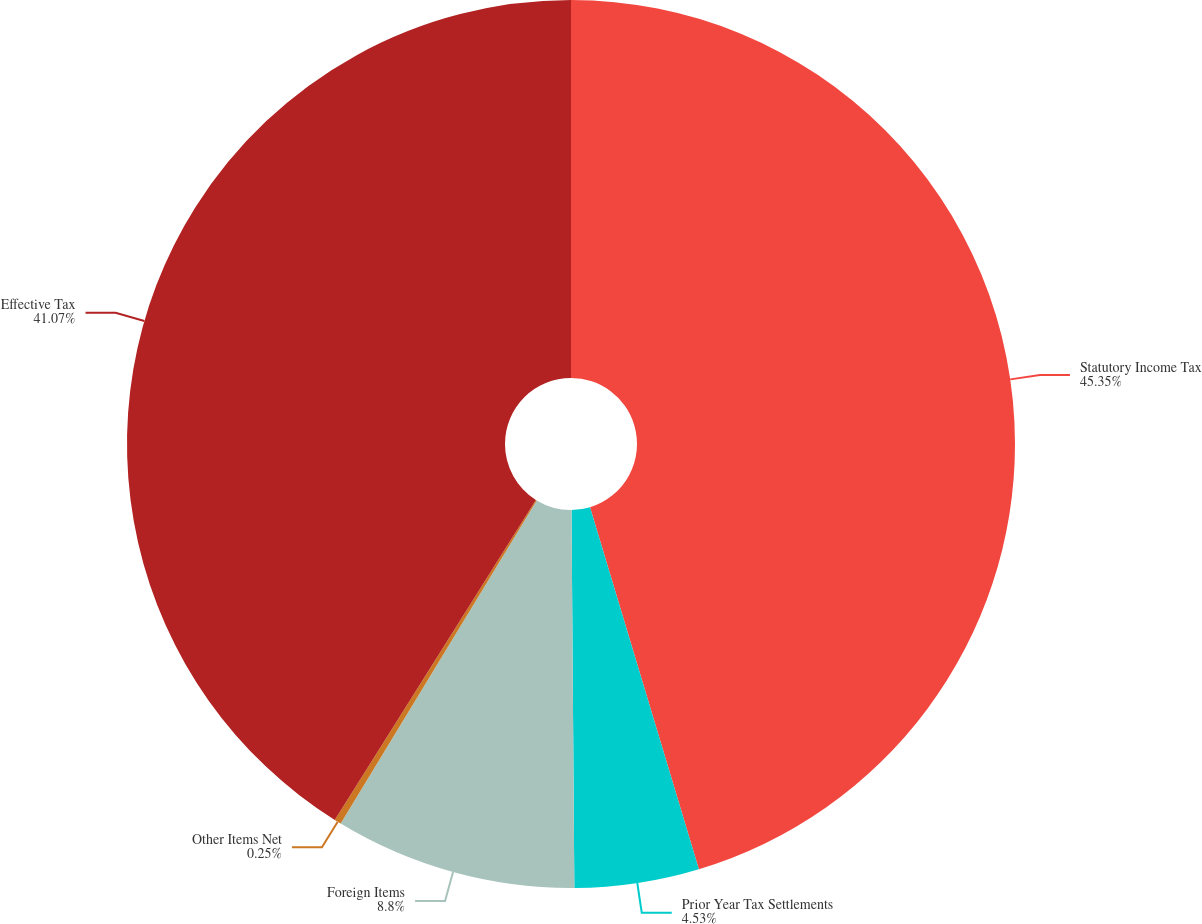Convert chart. <chart><loc_0><loc_0><loc_500><loc_500><pie_chart><fcel>Statutory Income Tax<fcel>Prior Year Tax Settlements<fcel>Foreign Items<fcel>Other Items Net<fcel>Effective Tax<nl><fcel>45.35%<fcel>4.53%<fcel>8.8%<fcel>0.25%<fcel>41.07%<nl></chart> 